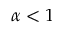<formula> <loc_0><loc_0><loc_500><loc_500>\alpha < 1</formula> 